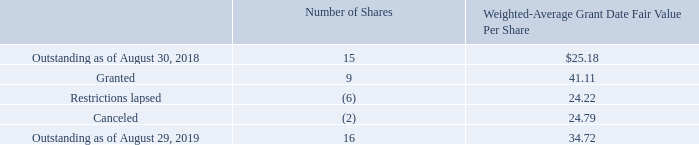Restricted Stock and Restricted Stock Units ("Restricted Stock Awards")
As of August 29, 2019, there were 16 million shares of Restricted Stock Awards outstanding, 14 million of which contained only service conditions. For service-based Restricted Stock Awards, restrictions generally lapse in one-fourth or one-third increments during each year of employment after the grant date. Restrictions lapse on Restricted Stock granted in 2019 with performance or market conditions over a three-year period if conditions are met. At the end of the performance period, the number of actual shares to be awarded will vary between 0% and 200% of target amounts, depending upon the achievement level. Restricted Stock Awards activity for 2019 is summarized as follows:
What is the total price of granted and restrictions lapsed stocks?
Answer scale should be: million. (9*41.11)+(-6*24.22) 
Answer: 224.67. What is the percentage change of the number of Restricted Stock Awards shares outstanding from August 30, 2018, to August 29, 2019?
Answer scale should be: percent. (16-15)/15 
Answer: 6.67. What is the price for service-based Restricted Stock Awards as of August 29, 2019?
Answer scale should be: million. 14*34.72 
Answer: 486.08. How many Restricted Stock Awards of shares were outstanding as of August 29, 2019? 16 million shares. What is the Weighted-Average Grant Date Fair Value Per Share for Granted stocks? 41.11. For service-based Restricted Stock Awards, when do the restrictions generally lapse? In one-fourth or one-third increments during each year of employment after the grant date. 